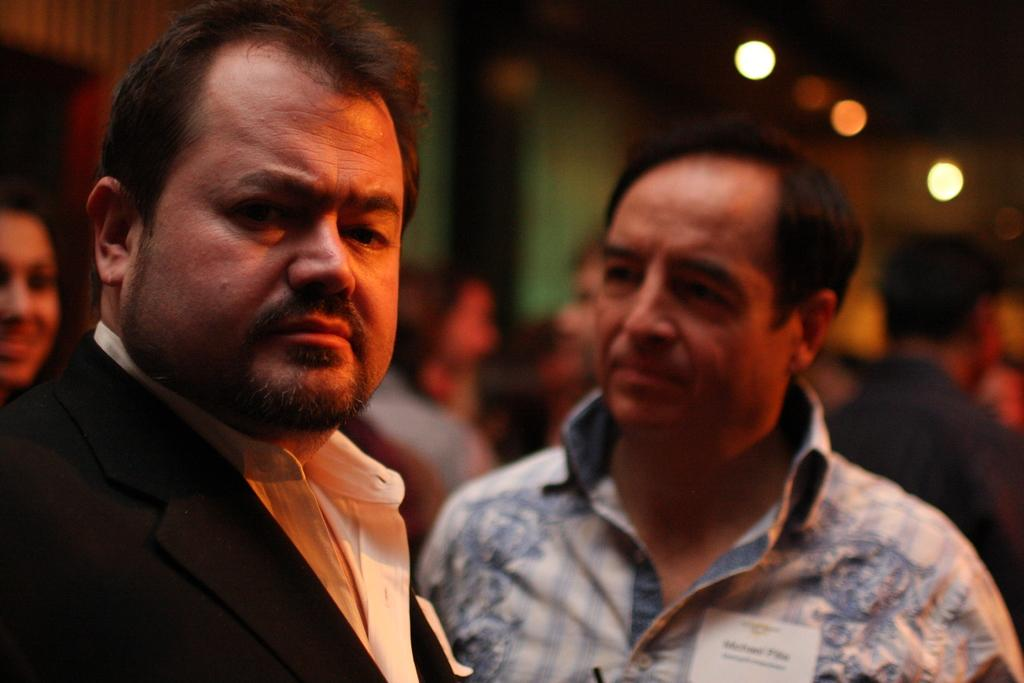What can be observed about the clothing of the people in the image? There are people with different color dresses in the image. Can you describe the setting in the background of the image? There are more people visible in the background of the image, and there are lights in the background as well. How is the background of the image depicted? The background is blurred. What type of language is being spoken by the people in the image? There is no information provided about the language being spoken in the image. Can you see any cherries or an egg in the image? There are no cherries or eggs present in the image. 